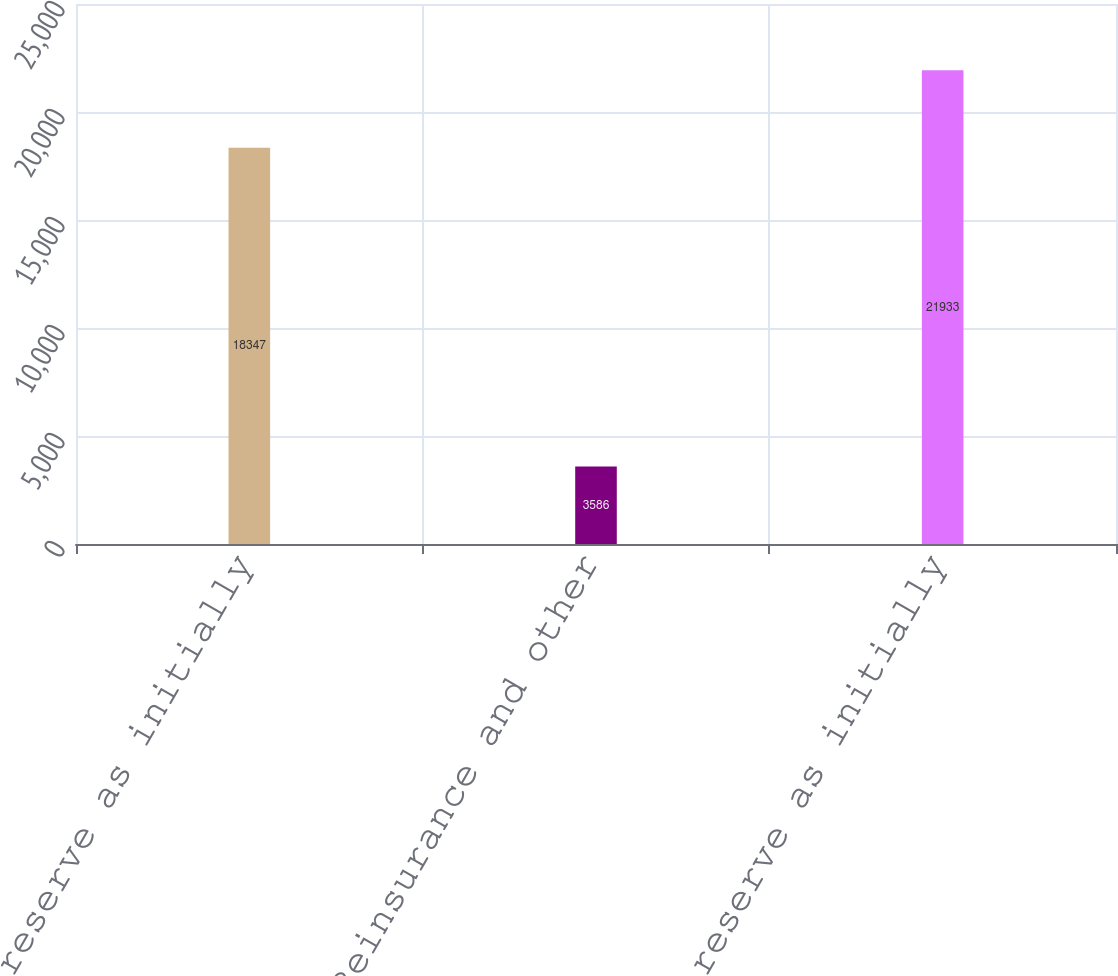Convert chart. <chart><loc_0><loc_0><loc_500><loc_500><bar_chart><fcel>Net reserve as initially<fcel>Reinsurance and other<fcel>Gross reserve as initially<nl><fcel>18347<fcel>3586<fcel>21933<nl></chart> 